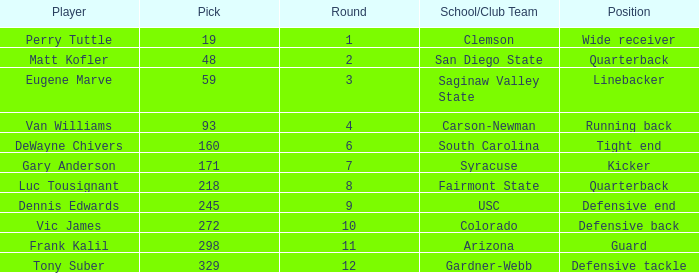Which player's pick is 160? DeWayne Chivers. Can you parse all the data within this table? {'header': ['Player', 'Pick', 'Round', 'School/Club Team', 'Position'], 'rows': [['Perry Tuttle', '19', '1', 'Clemson', 'Wide receiver'], ['Matt Kofler', '48', '2', 'San Diego State', 'Quarterback'], ['Eugene Marve', '59', '3', 'Saginaw Valley State', 'Linebacker'], ['Van Williams', '93', '4', 'Carson-Newman', 'Running back'], ['DeWayne Chivers', '160', '6', 'South Carolina', 'Tight end'], ['Gary Anderson', '171', '7', 'Syracuse', 'Kicker'], ['Luc Tousignant', '218', '8', 'Fairmont State', 'Quarterback'], ['Dennis Edwards', '245', '9', 'USC', 'Defensive end'], ['Vic James', '272', '10', 'Colorado', 'Defensive back'], ['Frank Kalil', '298', '11', 'Arizona', 'Guard'], ['Tony Suber', '329', '12', 'Gardner-Webb', 'Defensive tackle']]} 